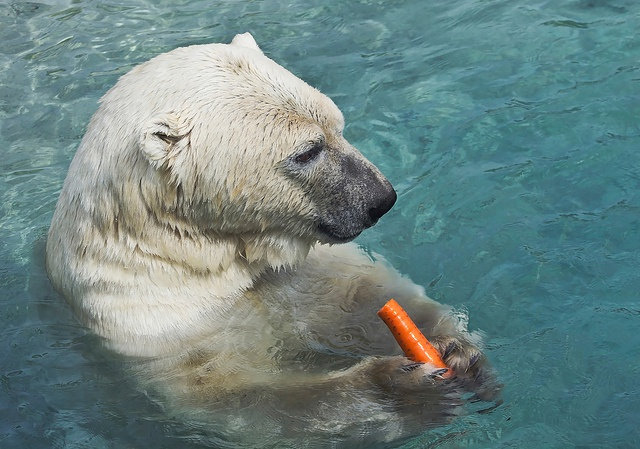Describe the objects in this image and their specific colors. I can see a carrot in darkgray, red, maroon, and orange tones in this image. 